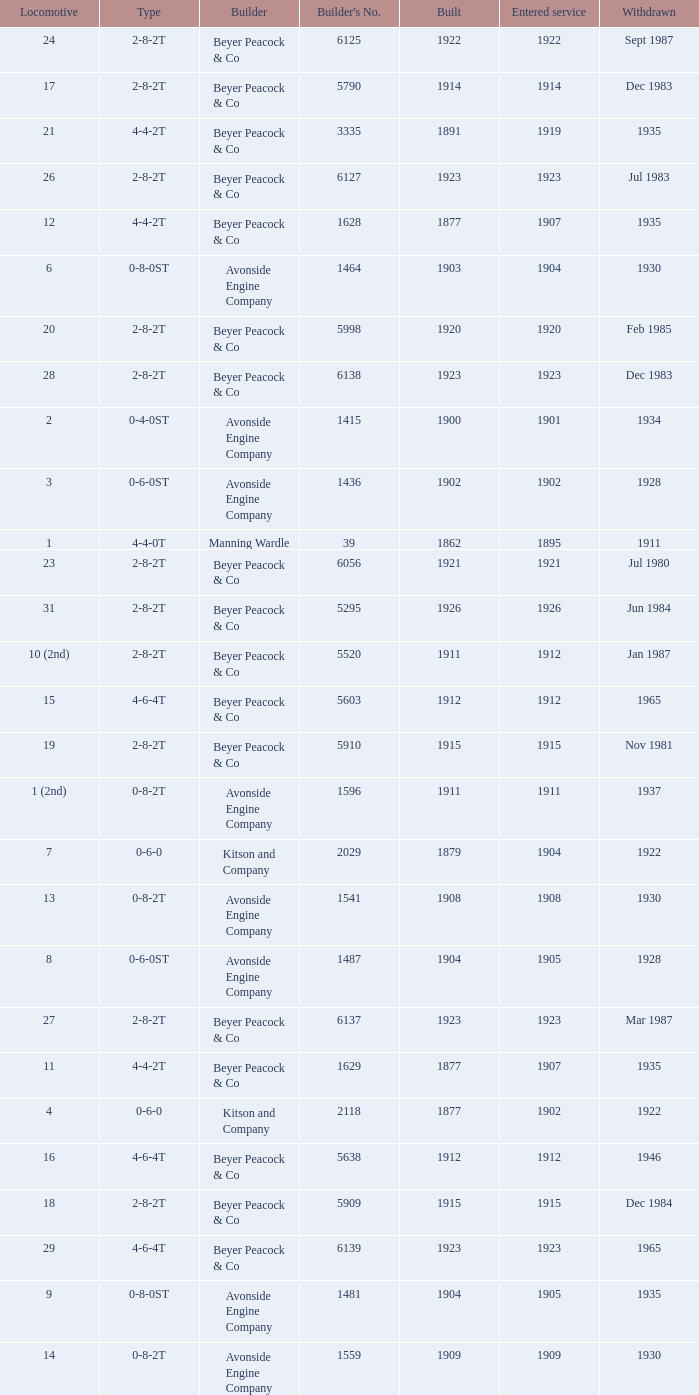Which locomotive had a 2-8-2t type, entered service year prior to 1915, and which was built after 1911? 17.0. 